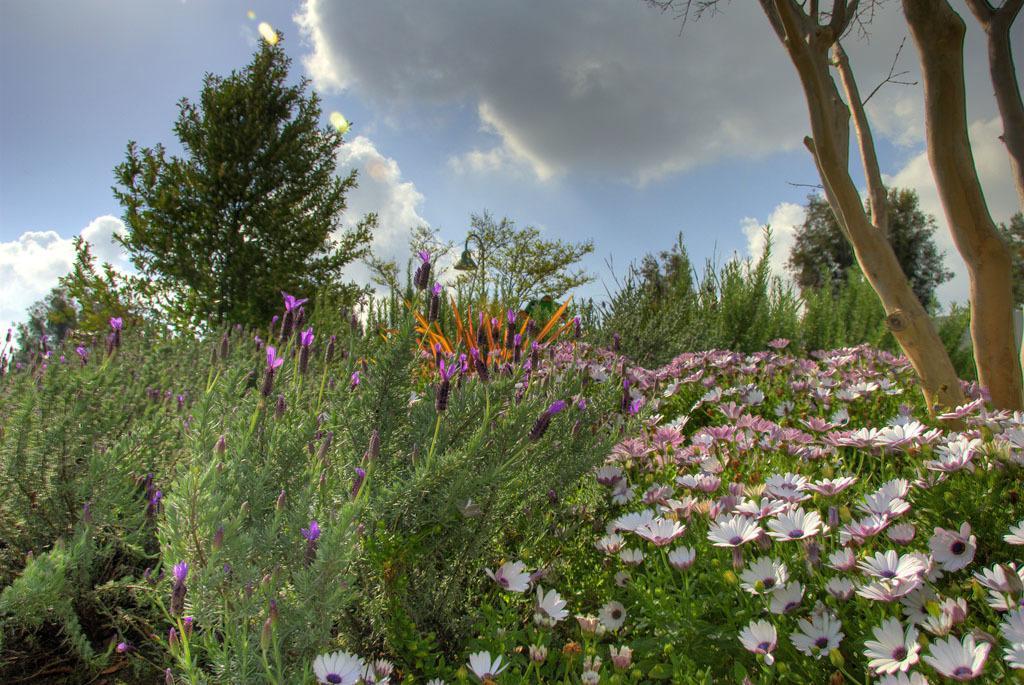Can you describe this image briefly? In this picture we can see trees,flowers and we can see sky in the background. 